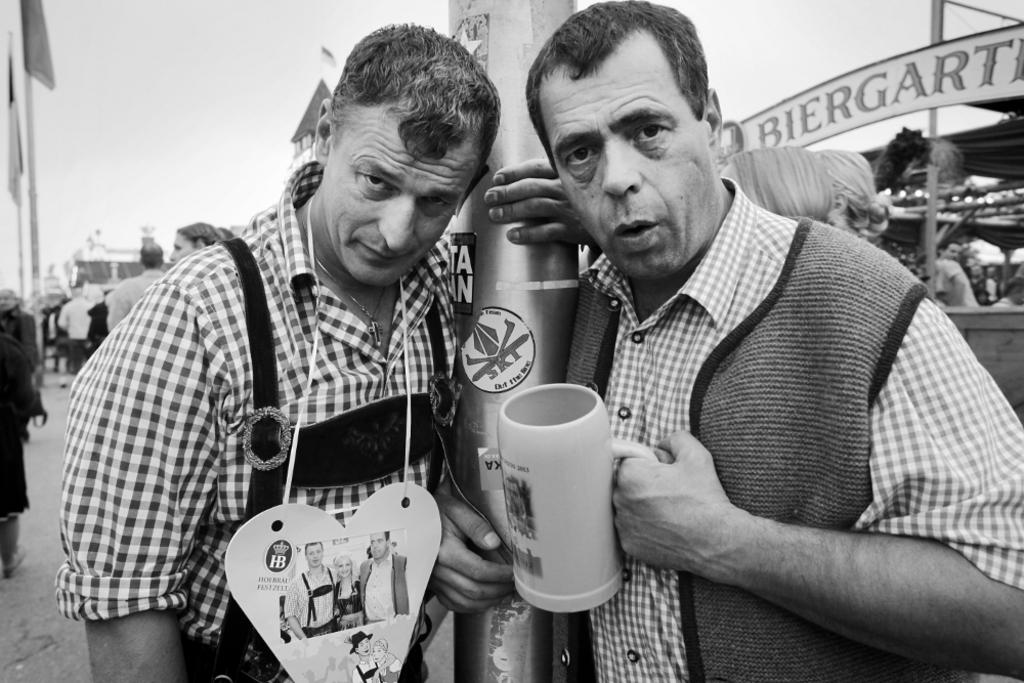What is the person on the right holding in the image? The person on the right is holding a glass in the image. What is the position of the person on the right? The person on the right is standing in the image. What is the person on the left doing in the image? The person on the left is holding a pillar in the image. Can you describe the person on the left's attire? The person on the left is wearing a tag in the image. What can be seen in the background of the image? There are many people and a name board in the background of the image. What type of tub is visible in the image? There is no tub present in the image. What flavor of soda is the person on the right drinking in the image? The person on the right is holding a glass, not drinking soda, so it cannot be determined what flavor they might be drinking. 